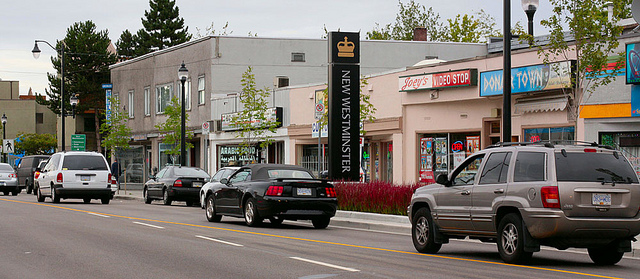<image>What is the man riding? It is unknown what the man is riding. It can be a car or an SUV. What is the man riding? I don't know what the man is riding. It can be a car or an SUV or it is also possible that there is no man riding anything. 